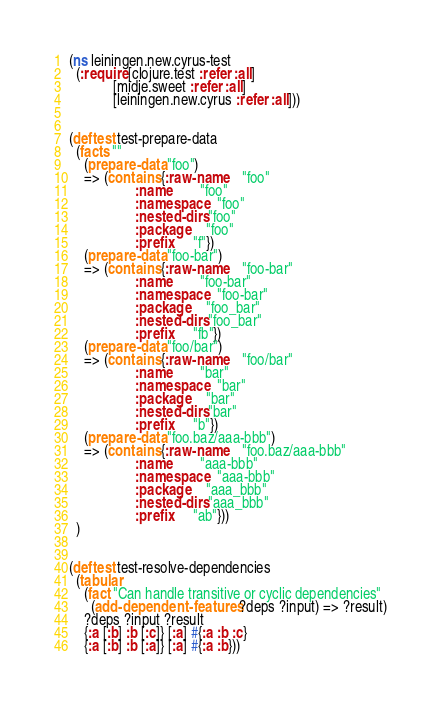<code> <loc_0><loc_0><loc_500><loc_500><_Clojure_>(ns leiningen.new.cyrus-test
  (:require [clojure.test :refer :all]
            [midje.sweet :refer :all]
            [leiningen.new.cyrus :refer :all]))


(deftest test-prepare-data
  (facts ""
    (prepare-data "foo")
    => (contains {:raw-name    "foo"
                  :name        "foo"
                  :namespace   "foo"
                  :nested-dirs "foo"
                  :package     "foo"
                  :prefix      "f"})
    (prepare-data "foo-bar")
    => (contains {:raw-name    "foo-bar"
                  :name        "foo-bar"
                  :namespace   "foo-bar"
                  :package     "foo_bar"
                  :nested-dirs "foo_bar"
                  :prefix      "fb"})
    (prepare-data "foo/bar")
    => (contains {:raw-name    "foo/bar"
                  :name        "bar"
                  :namespace   "bar"
                  :package     "bar"
                  :nested-dirs "bar"
                  :prefix      "b"})
    (prepare-data "foo.baz/aaa-bbb")
    => (contains {:raw-name    "foo.baz/aaa-bbb"
                  :name        "aaa-bbb"
                  :namespace   "aaa-bbb"
                  :package     "aaa_bbb"
                  :nested-dirs "aaa_bbb"
                  :prefix      "ab"}))
  )


(deftest test-resolve-dependencies
  (tabular
    (fact "Can handle transitive or cyclic dependencies"
      (add-dependent-features ?deps ?input) => ?result)
    ?deps ?input ?result
    {:a [:b] :b [:c]} [:a] #{:a :b :c}
    {:a [:b] :b [:a]} [:a] #{:a :b}))
</code> 